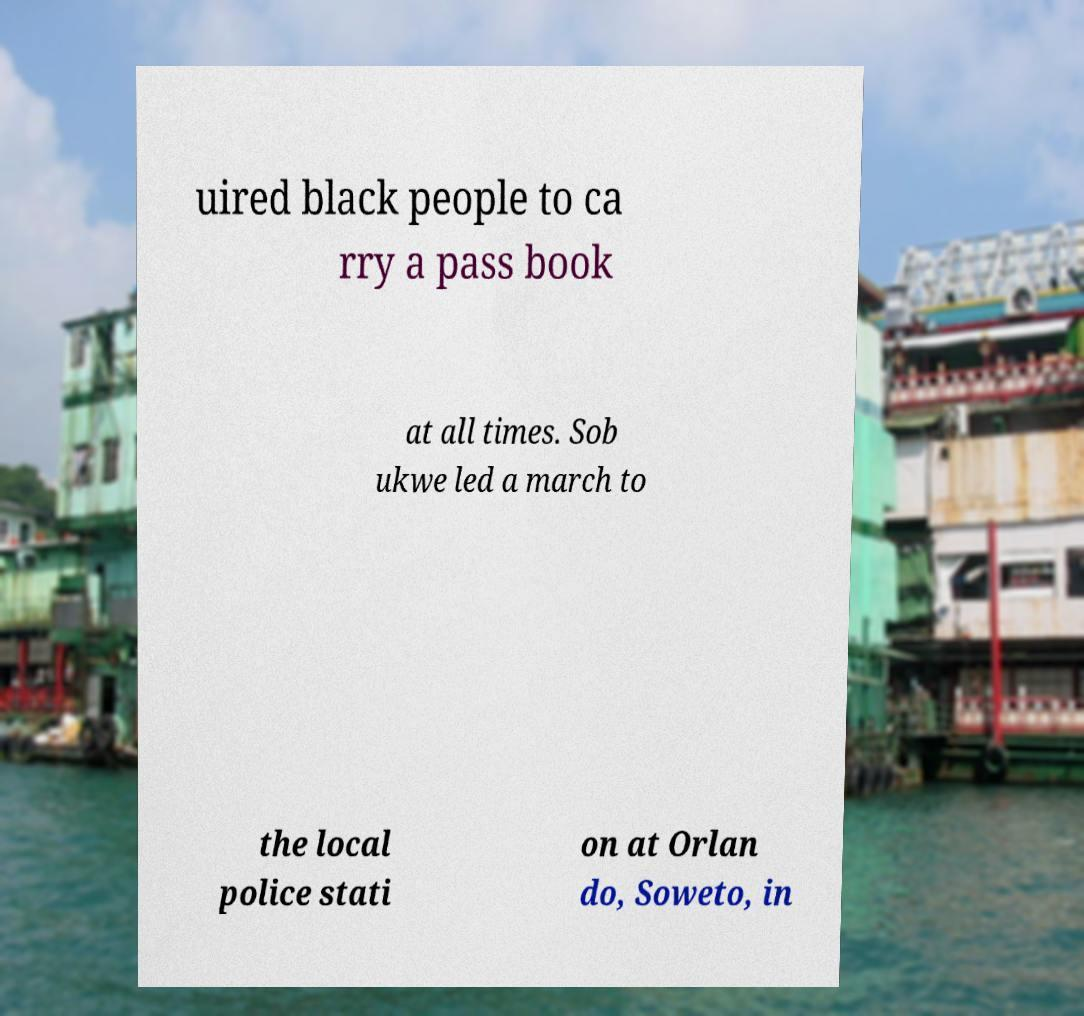Could you extract and type out the text from this image? uired black people to ca rry a pass book at all times. Sob ukwe led a march to the local police stati on at Orlan do, Soweto, in 